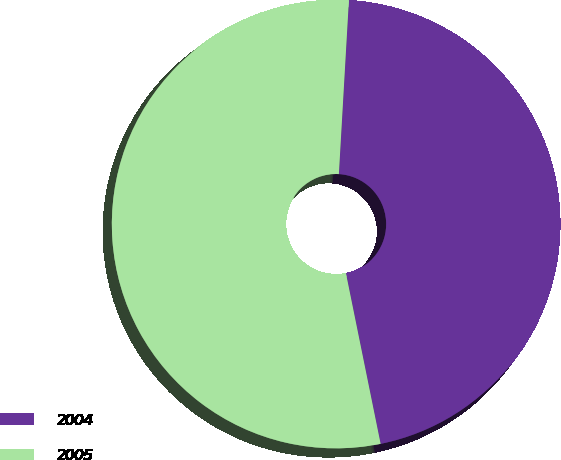<chart> <loc_0><loc_0><loc_500><loc_500><pie_chart><fcel>2004<fcel>2005<nl><fcel>45.89%<fcel>54.11%<nl></chart> 